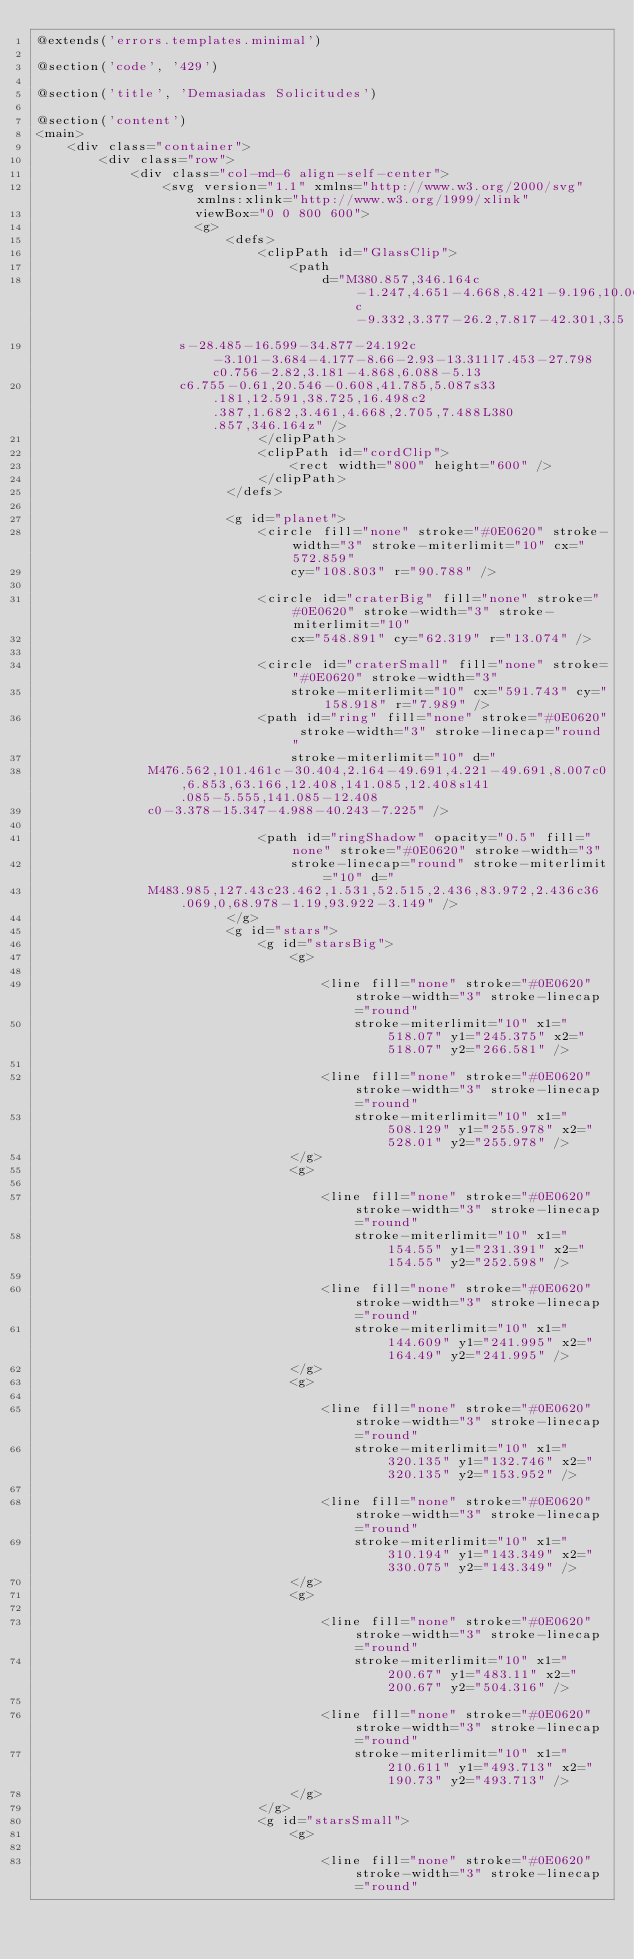Convert code to text. <code><loc_0><loc_0><loc_500><loc_500><_PHP_>@extends('errors.templates.minimal')

@section('code', '429')

@section('title', 'Demasiadas Solicitudes')

@section('content')
<main>
    <div class="container">
        <div class="row">
            <div class="col-md-6 align-self-center">
                <svg version="1.1" xmlns="http://www.w3.org/2000/svg" xmlns:xlink="http://www.w3.org/1999/xlink"
                    viewBox="0 0 800 600">
                    <g>
                        <defs>
                            <clipPath id="GlassClip">
                                <path
                                    d="M380.857,346.164c-1.247,4.651-4.668,8.421-9.196,10.06c-9.332,3.377-26.2,7.817-42.301,3.5
                  s-28.485-16.599-34.877-24.192c-3.101-3.684-4.177-8.66-2.93-13.311l7.453-27.798c0.756-2.82,3.181-4.868,6.088-5.13
                  c6.755-0.61,20.546-0.608,41.785,5.087s33.181,12.591,38.725,16.498c2.387,1.682,3.461,4.668,2.705,7.488L380.857,346.164z" />
                            </clipPath>
                            <clipPath id="cordClip">
                                <rect width="800" height="600" />
                            </clipPath>
                        </defs>

                        <g id="planet">
                            <circle fill="none" stroke="#0E0620" stroke-width="3" stroke-miterlimit="10" cx="572.859"
                                cy="108.803" r="90.788" />

                            <circle id="craterBig" fill="none" stroke="#0E0620" stroke-width="3" stroke-miterlimit="10"
                                cx="548.891" cy="62.319" r="13.074" />

                            <circle id="craterSmall" fill="none" stroke="#0E0620" stroke-width="3"
                                stroke-miterlimit="10" cx="591.743" cy="158.918" r="7.989" />
                            <path id="ring" fill="none" stroke="#0E0620" stroke-width="3" stroke-linecap="round"
                                stroke-miterlimit="10" d="
              M476.562,101.461c-30.404,2.164-49.691,4.221-49.691,8.007c0,6.853,63.166,12.408,141.085,12.408s141.085-5.555,141.085-12.408
              c0-3.378-15.347-4.988-40.243-7.225" />

                            <path id="ringShadow" opacity="0.5" fill="none" stroke="#0E0620" stroke-width="3"
                                stroke-linecap="round" stroke-miterlimit="10" d="
              M483.985,127.43c23.462,1.531,52.515,2.436,83.972,2.436c36.069,0,68.978-1.19,93.922-3.149" />
                        </g>
                        <g id="stars">
                            <g id="starsBig">
                                <g>

                                    <line fill="none" stroke="#0E0620" stroke-width="3" stroke-linecap="round"
                                        stroke-miterlimit="10" x1="518.07" y1="245.375" x2="518.07" y2="266.581" />

                                    <line fill="none" stroke="#0E0620" stroke-width="3" stroke-linecap="round"
                                        stroke-miterlimit="10" x1="508.129" y1="255.978" x2="528.01" y2="255.978" />
                                </g>
                                <g>

                                    <line fill="none" stroke="#0E0620" stroke-width="3" stroke-linecap="round"
                                        stroke-miterlimit="10" x1="154.55" y1="231.391" x2="154.55" y2="252.598" />

                                    <line fill="none" stroke="#0E0620" stroke-width="3" stroke-linecap="round"
                                        stroke-miterlimit="10" x1="144.609" y1="241.995" x2="164.49" y2="241.995" />
                                </g>
                                <g>

                                    <line fill="none" stroke="#0E0620" stroke-width="3" stroke-linecap="round"
                                        stroke-miterlimit="10" x1="320.135" y1="132.746" x2="320.135" y2="153.952" />

                                    <line fill="none" stroke="#0E0620" stroke-width="3" stroke-linecap="round"
                                        stroke-miterlimit="10" x1="310.194" y1="143.349" x2="330.075" y2="143.349" />
                                </g>
                                <g>

                                    <line fill="none" stroke="#0E0620" stroke-width="3" stroke-linecap="round"
                                        stroke-miterlimit="10" x1="200.67" y1="483.11" x2="200.67" y2="504.316" />

                                    <line fill="none" stroke="#0E0620" stroke-width="3" stroke-linecap="round"
                                        stroke-miterlimit="10" x1="210.611" y1="493.713" x2="190.73" y2="493.713" />
                                </g>
                            </g>
                            <g id="starsSmall">
                                <g>

                                    <line fill="none" stroke="#0E0620" stroke-width="3" stroke-linecap="round"</code> 